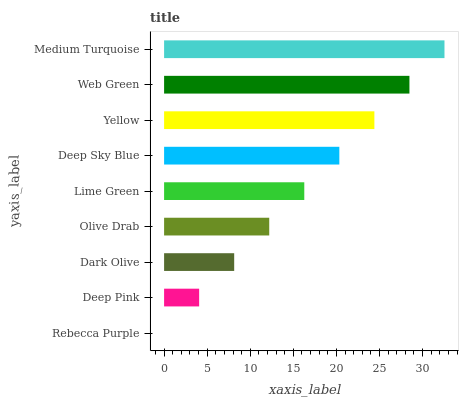Is Rebecca Purple the minimum?
Answer yes or no. Yes. Is Medium Turquoise the maximum?
Answer yes or no. Yes. Is Deep Pink the minimum?
Answer yes or no. No. Is Deep Pink the maximum?
Answer yes or no. No. Is Deep Pink greater than Rebecca Purple?
Answer yes or no. Yes. Is Rebecca Purple less than Deep Pink?
Answer yes or no. Yes. Is Rebecca Purple greater than Deep Pink?
Answer yes or no. No. Is Deep Pink less than Rebecca Purple?
Answer yes or no. No. Is Lime Green the high median?
Answer yes or no. Yes. Is Lime Green the low median?
Answer yes or no. Yes. Is Deep Pink the high median?
Answer yes or no. No. Is Yellow the low median?
Answer yes or no. No. 